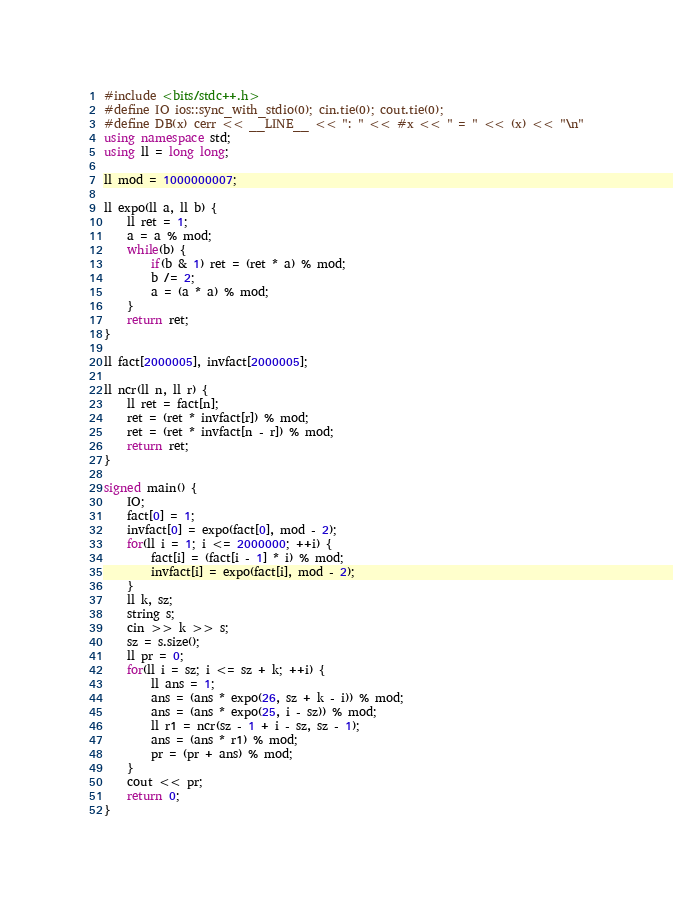Convert code to text. <code><loc_0><loc_0><loc_500><loc_500><_C++_>#include <bits/stdc++.h>
#define IO ios::sync_with_stdio(0); cin.tie(0); cout.tie(0);
#define DB(x) cerr << __LINE__ << ": " << #x << " = " << (x) << "\n"
using namespace std;
using ll = long long;

ll mod = 1000000007;

ll expo(ll a, ll b) {
	ll ret = 1;
	a = a % mod;
	while(b) {
		if(b & 1) ret = (ret * a) % mod;
		b /= 2;
		a = (a * a) % mod;
	}
	return ret;
}

ll fact[2000005], invfact[2000005];

ll ncr(ll n, ll r) {
	ll ret = fact[n];
	ret = (ret * invfact[r]) % mod;
	ret = (ret * invfact[n - r]) % mod;
	return ret;
}

signed main() {
    IO;
    fact[0] = 1;
    invfact[0] = expo(fact[0], mod - 2);
    for(ll i = 1; i <= 2000000; ++i) {
    	fact[i] = (fact[i - 1] * i) % mod;
    	invfact[i] = expo(fact[i], mod - 2);
    }
    ll k, sz;
    string s;
    cin >> k >> s;
    sz = s.size();
    ll pr = 0;
    for(ll i = sz; i <= sz + k; ++i) {
    	ll ans = 1;
    	ans = (ans * expo(26, sz + k - i)) % mod;
    	ans = (ans * expo(25, i - sz)) % mod;
    	ll r1 = ncr(sz - 1 + i - sz, sz - 1);
    	ans = (ans * r1) % mod;
    	pr = (pr + ans) % mod;
    }
    cout << pr;
    return 0;
}
</code> 